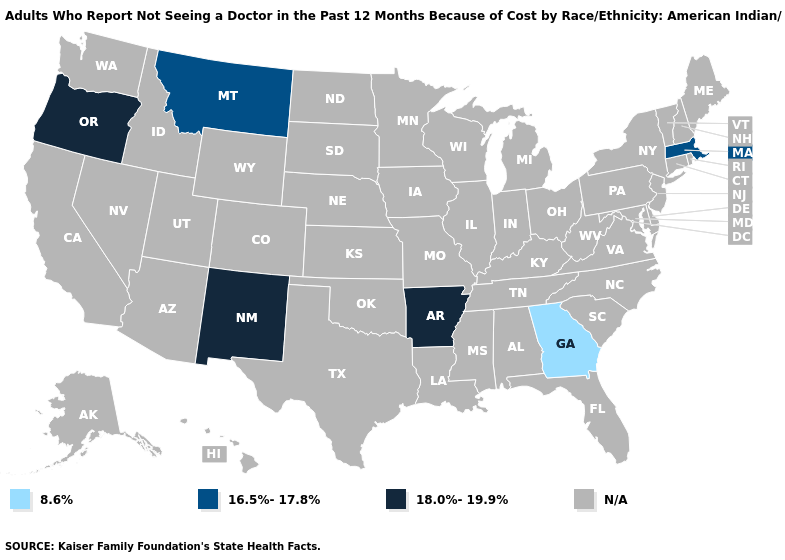Does Georgia have the highest value in the South?
Answer briefly. No. What is the value of Alaska?
Answer briefly. N/A. Name the states that have a value in the range 8.6%?
Give a very brief answer. Georgia. Name the states that have a value in the range N/A?
Answer briefly. Alabama, Alaska, Arizona, California, Colorado, Connecticut, Delaware, Florida, Hawaii, Idaho, Illinois, Indiana, Iowa, Kansas, Kentucky, Louisiana, Maine, Maryland, Michigan, Minnesota, Mississippi, Missouri, Nebraska, Nevada, New Hampshire, New Jersey, New York, North Carolina, North Dakota, Ohio, Oklahoma, Pennsylvania, Rhode Island, South Carolina, South Dakota, Tennessee, Texas, Utah, Vermont, Virginia, Washington, West Virginia, Wisconsin, Wyoming. What is the value of New Jersey?
Answer briefly. N/A. Name the states that have a value in the range N/A?
Give a very brief answer. Alabama, Alaska, Arizona, California, Colorado, Connecticut, Delaware, Florida, Hawaii, Idaho, Illinois, Indiana, Iowa, Kansas, Kentucky, Louisiana, Maine, Maryland, Michigan, Minnesota, Mississippi, Missouri, Nebraska, Nevada, New Hampshire, New Jersey, New York, North Carolina, North Dakota, Ohio, Oklahoma, Pennsylvania, Rhode Island, South Carolina, South Dakota, Tennessee, Texas, Utah, Vermont, Virginia, Washington, West Virginia, Wisconsin, Wyoming. What is the value of Kansas?
Answer briefly. N/A. What is the value of Maine?
Give a very brief answer. N/A. What is the value of Alaska?
Short answer required. N/A. What is the value of Arizona?
Be succinct. N/A. Name the states that have a value in the range 8.6%?
Give a very brief answer. Georgia. What is the highest value in the USA?
Write a very short answer. 18.0%-19.9%. Does the map have missing data?
Be succinct. Yes. 